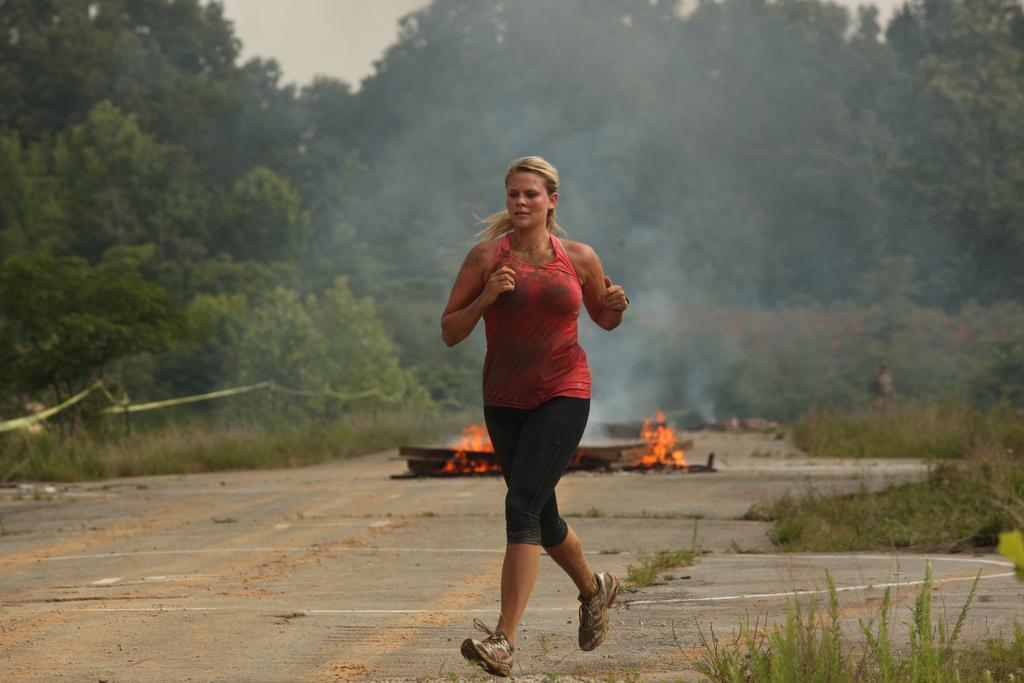Who is the main subject in the image? There is a woman in the image. What is the woman doing in the image? The woman is running on the ground. What type of natural environment can be seen in the image? There are trees visible in the image. What is the source of light in the image? There is fire in the image, which could be providing light. What else can be seen in the image besides the woman and trees? There are objects visible in the image. What is visible in the background of the image? The sky is visible in the background of the image. What type of instrument is the woman playing in the image? There is no instrument present in the image; the woman is running. What language is the woman speaking in the image? There is no indication of the woman speaking in the image, so it cannot be determined which language she might be using. 